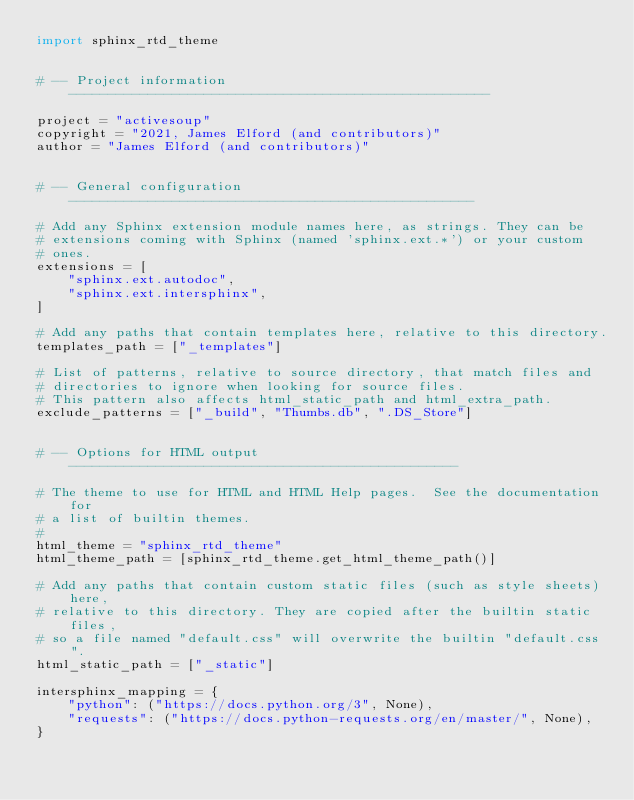<code> <loc_0><loc_0><loc_500><loc_500><_Python_>import sphinx_rtd_theme


# -- Project information -----------------------------------------------------

project = "activesoup"
copyright = "2021, James Elford (and contributors)"
author = "James Elford (and contributors)"


# -- General configuration ---------------------------------------------------

# Add any Sphinx extension module names here, as strings. They can be
# extensions coming with Sphinx (named 'sphinx.ext.*') or your custom
# ones.
extensions = [
    "sphinx.ext.autodoc",
    "sphinx.ext.intersphinx",
]

# Add any paths that contain templates here, relative to this directory.
templates_path = ["_templates"]

# List of patterns, relative to source directory, that match files and
# directories to ignore when looking for source files.
# This pattern also affects html_static_path and html_extra_path.
exclude_patterns = ["_build", "Thumbs.db", ".DS_Store"]


# -- Options for HTML output -------------------------------------------------

# The theme to use for HTML and HTML Help pages.  See the documentation for
# a list of builtin themes.
#
html_theme = "sphinx_rtd_theme"
html_theme_path = [sphinx_rtd_theme.get_html_theme_path()]

# Add any paths that contain custom static files (such as style sheets) here,
# relative to this directory. They are copied after the builtin static files,
# so a file named "default.css" will overwrite the builtin "default.css".
html_static_path = ["_static"]

intersphinx_mapping = {
    "python": ("https://docs.python.org/3", None),
    "requests": ("https://docs.python-requests.org/en/master/", None),
}
</code> 